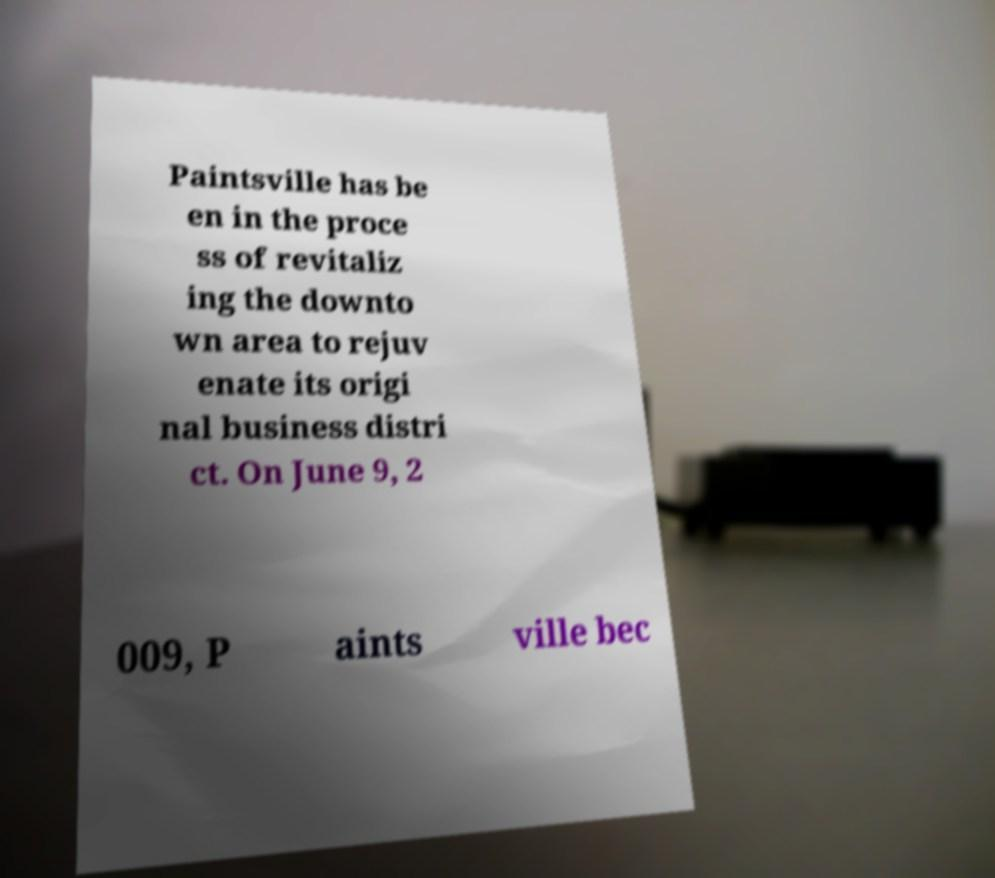Can you read and provide the text displayed in the image?This photo seems to have some interesting text. Can you extract and type it out for me? Paintsville has be en in the proce ss of revitaliz ing the downto wn area to rejuv enate its origi nal business distri ct. On June 9, 2 009, P aints ville bec 